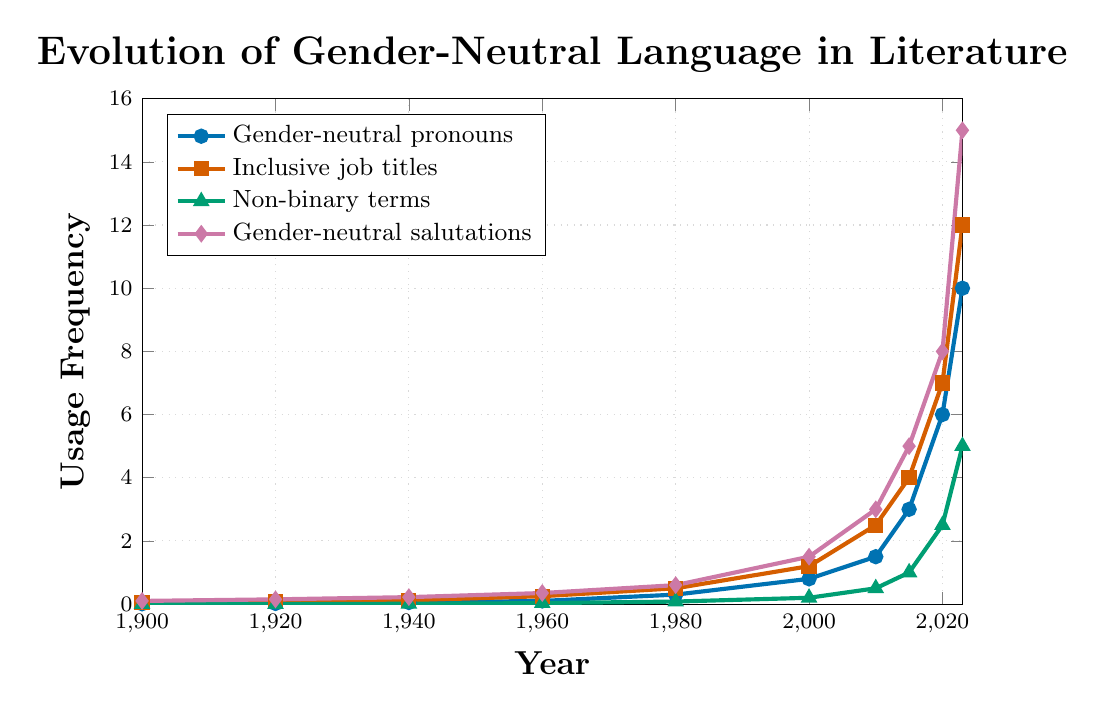How has the usage of gender-neutral pronouns changed from 1900 to 2023? Using the figure, we see the data points for gender-neutral pronouns starting at 0.01 in 1900 and rising steadily to 10 in 2023.
Answer: Steadily increased Which category saw the greatest increase in usage from 1980 to 2023? Analyze the starting and ending points for all categories in 1980 and 2023. Gender-neutral salutations increased from 0.6 to 15, which is the largest change.
Answer: Gender-neutral salutations What is the difference in usage frequency between inclusive job titles and non-binary terms in 2015? Referring to the figure, in 2015, inclusive job titles are at 4 and non-binary terms are at 1. The difference is 4 - 1 = 3.
Answer: 3 In which year did gender-neutral pronouns surpass the usage of inclusive job titles for the first time? Check the intersection point of the curves for gender-neutral pronouns and inclusive job titles. This first occurs around 2020.
Answer: 2020 How much did gender-neutral salutations increase from 2000 to 2010? From the figure, gender-neutral salutations in 2000 is at 1.5 and in 2010 is 3. The increase is 3 - 1.5 = 1.5.
Answer: 1.5 At what year did the usage frequency of non-binary terms reach 2.5? According to the figure, non-binary terms hit 2.5 in 2020.
Answer: 2020 Compare the usage frequency of gender-neutral pronouns and gender-neutral salutations in 2000. Which was higher? In 2000, gender-neutral pronouns are at 0.8 and gender-neutral salutations are at 1.5. Gender-neutral salutations are higher.
Answer: Gender-neutral salutations What is the average usage frequency of gender-neutral salutations from 1940 to 2023? Sum the values for gender-neutral salutations at each year from 1940 to 2023 and divide by the number of recorded years. (0.22 + 0.35 + 0.6 + 1.5 + 3 + 5 + 8 + 15) / 8 = 4.7
Answer: 4.7 How many years after 1900 did the usage frequency of gender-neutral pronouns first exceed 1? Gender-neutral pronouns exceeded 1 for the first time in 2010. 2010 - 1900 = 110 years.
Answer: 110 years Which category reached a usage frequency of 12 first, inclusive job titles or gender-neutral salutations? Check the years when inclusive job titles and gender-neutral salutations reach 12. Inclusive job titles reached 12 in 2023, while gender-neutral salutations were not shown to reach 12 exactly; comparing any trends, the actual year is  more ambiguous.
Answer: Not clearly indicated; trends suggest a comparison dilemma 